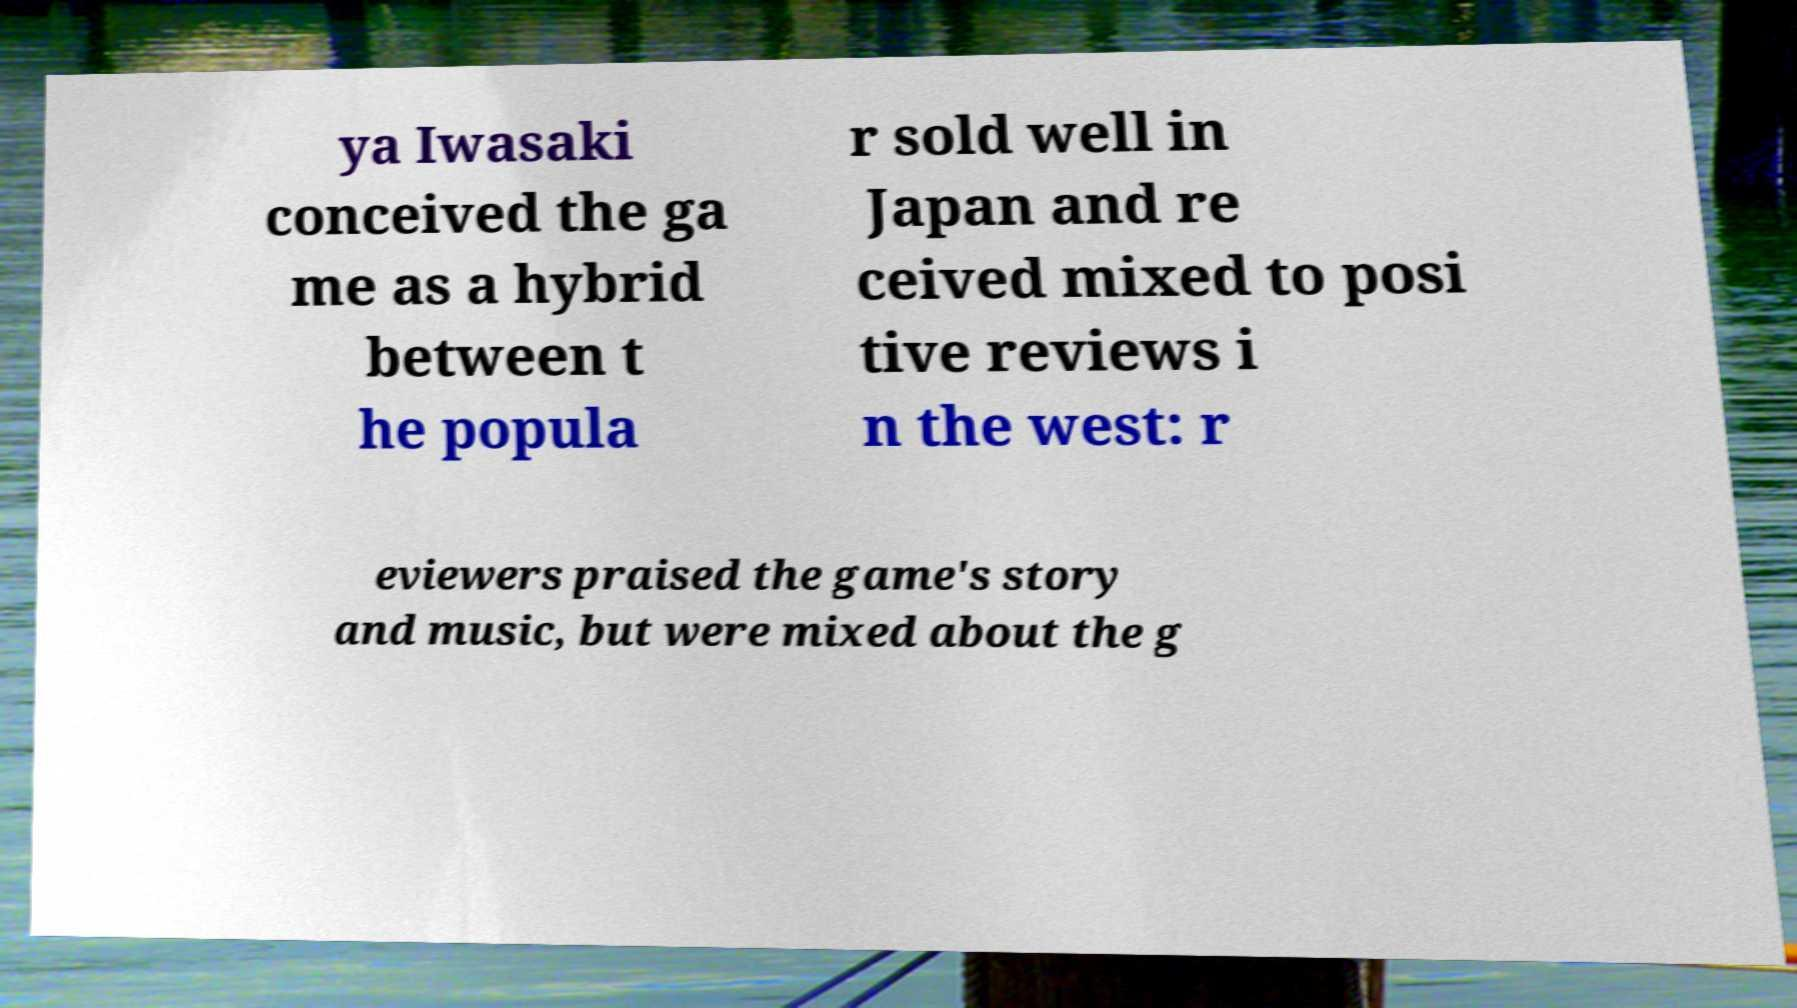Please identify and transcribe the text found in this image. ya Iwasaki conceived the ga me as a hybrid between t he popula r sold well in Japan and re ceived mixed to posi tive reviews i n the west: r eviewers praised the game's story and music, but were mixed about the g 